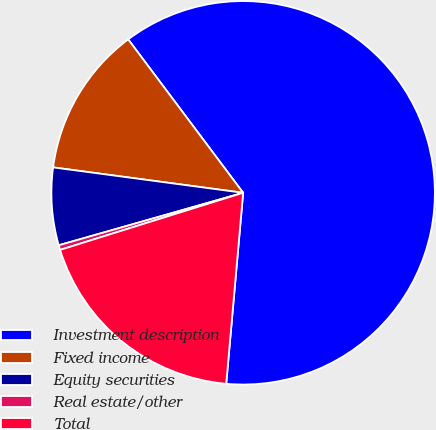Convert chart to OTSL. <chart><loc_0><loc_0><loc_500><loc_500><pie_chart><fcel>Investment description<fcel>Fixed income<fcel>Equity securities<fcel>Real estate/other<fcel>Total<nl><fcel>61.64%<fcel>12.65%<fcel>6.53%<fcel>0.4%<fcel>18.78%<nl></chart> 